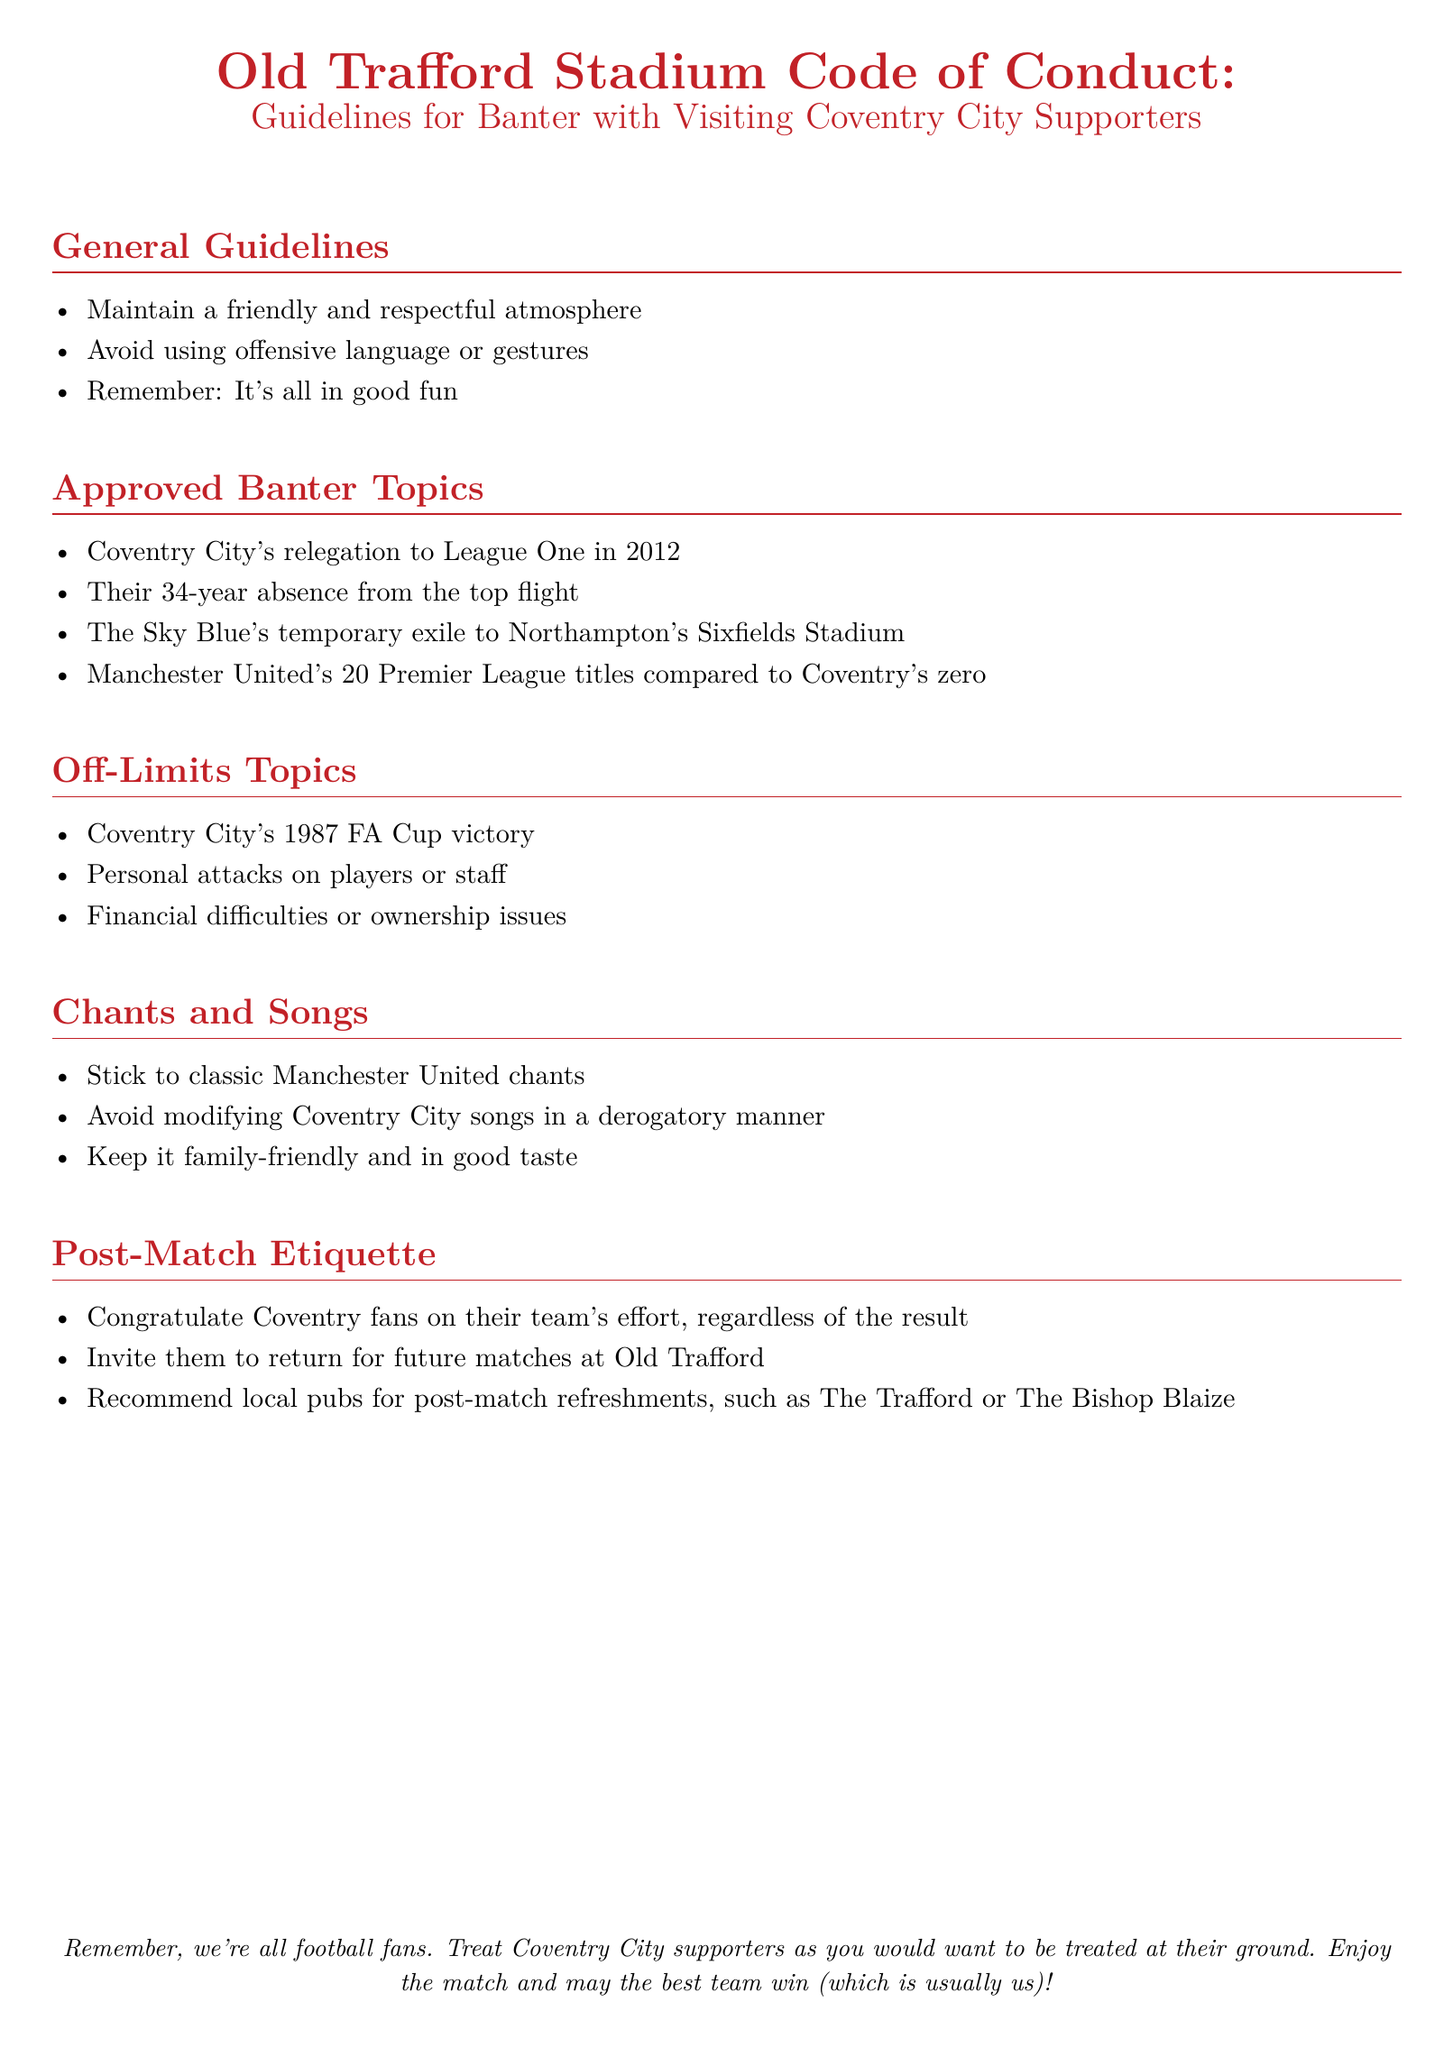What is the document about? The document provides guidelines for banter with visiting Coventry City supporters at Old Trafford.
Answer: Guidelines for Banter with Visiting Coventry City Supporters How many Premier League titles does Manchester United have according to the document? The document states that Manchester United has 20 Premier League titles compared to Coventry's zero.
Answer: 20 What year did Coventry City get relegated to League One? The document mentions Coventry City's relegation to League One occurred in 2012.
Answer: 2012 What is one chant guideline mentioned in the document? The document instructs to stick to classic Manchester United chants.
Answer: Stick to classic Manchester United chants Which FA Cup victory is off-limits for banter? The document specifies that Coventry City's 1987 FA Cup victory is an off-limits topic.
Answer: 1987 FA Cup victory What should be done after the match regardless of the result? The document advises to congratulate Coventry fans on their team's effort.
Answer: Congratulate Coventry fans What type of atmosphere should be maintained during banter? The document suggests maintaining a friendly and respectful atmosphere during banter.
Answer: Friendly and respectful atmosphere What is one recommended local pub mentioned for post-match refreshments? The document lists The Trafford as a recommended local pub for post-match refreshments.
Answer: The Trafford 